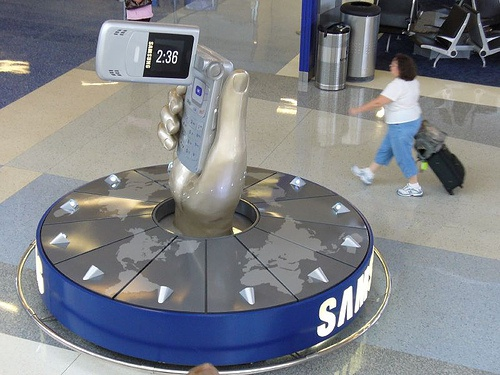Describe the objects in this image and their specific colors. I can see cell phone in gray, darkgray, black, and lightgray tones, people in gray, lightgray, and darkgray tones, suitcase in gray and black tones, and people in gray, pink, black, and darkgray tones in this image. 